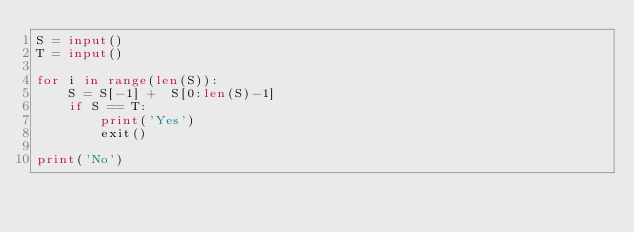Convert code to text. <code><loc_0><loc_0><loc_500><loc_500><_Python_>S = input()
T = input()

for i in range(len(S)):
    S = S[-1] +  S[0:len(S)-1]
    if S == T:
        print('Yes')
        exit()

print('No')</code> 